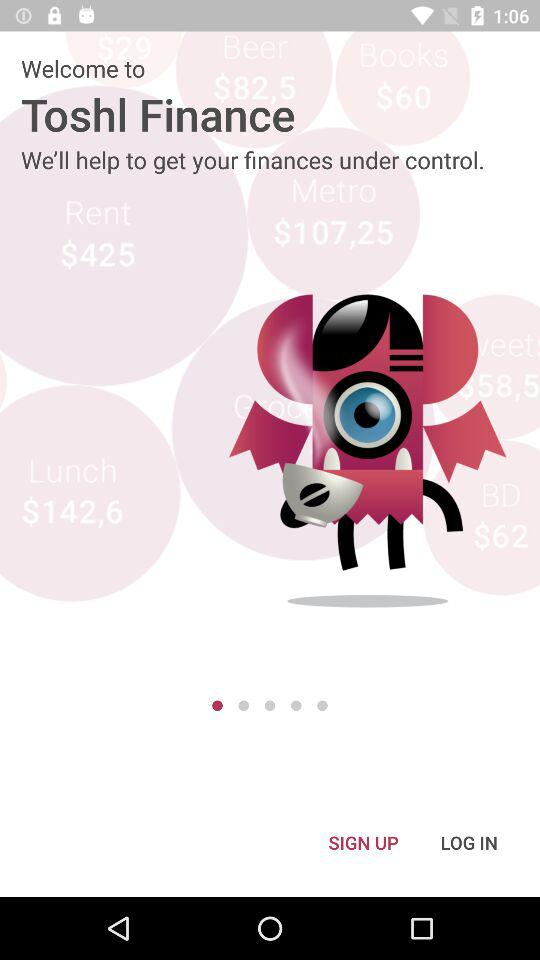What is the application name? The application name is "Toshl Finance". 